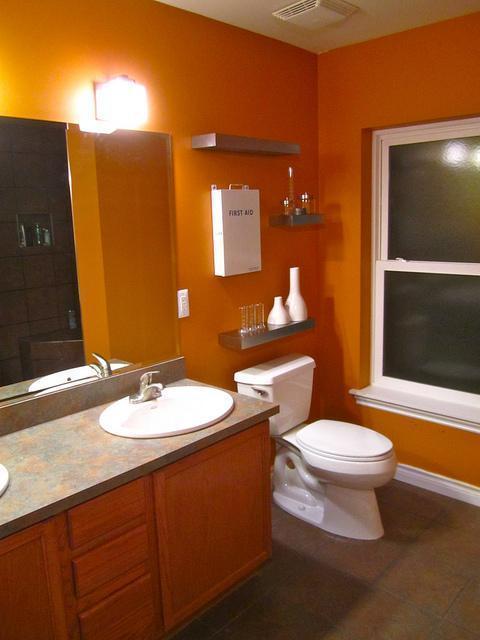How many cabinets are above the sink?
Give a very brief answer. 0. How many toilets are there?
Give a very brief answer. 1. 